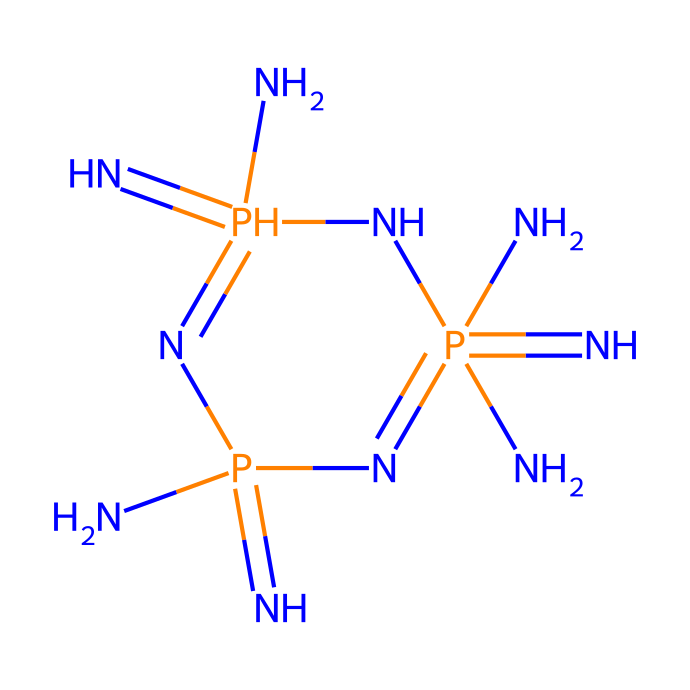What is the central atom in this structure? The central atom of the structure is phosphorus, as indicated by its position and the presence of surrounding nitrogen atoms in phosphazene bases.
Answer: phosphorus How many nitrogen atoms are present in this molecule? By examining the molecular structure, we can count a total of 6 nitrogen atoms that are bonded to the phosphorus atoms.
Answer: 6 What type of bonding is primarily present in this molecule? The molecule primarily exhibits covalent bonding, evident from the connections between nitrogen and phosphorus atoms sharing electrons, characteristic of phosphazene superbases.
Answer: covalent What is the molecular formula of this compound? Analyzing the arrangement and counts of each atom, the molecular formula can be derived as N6P2, representing 6 nitrogen atoms and 2 phosphorus atoms in the structure.
Answer: N6P2 Which functional group is significant in this chemical for its superbase property? The presence of the multiple nitrogen atoms creates amino functional groups, which contribute significantly to the superbase nature by providing basicity and electron donation capability.
Answer: amino How does the arrangement of atoms contribute to its application in fuel cells? The specific arrangement allows for high electron density due to the nitrogen's basicity, facilitating proton transfer and enhancing conductivity, essential for fuel cell performance.
Answer: electron density What is the significance of phosphorus in the context of this superbase? Phosphorus is crucial as it acts as a central atom coordinating with nitrogen, enhancing the overall stability and basicity of the superbase, which is needed in catalytic applications.
Answer: stability 